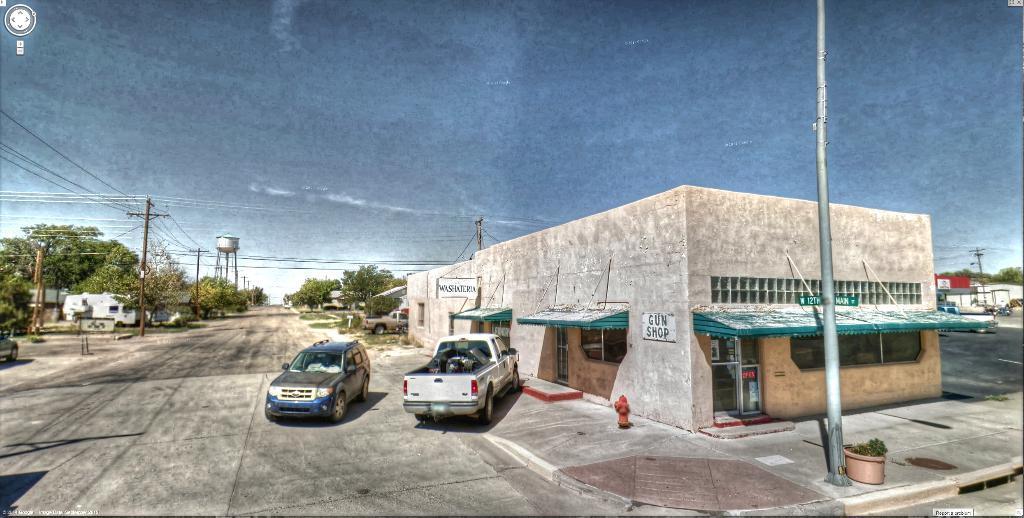Describe this image in one or two sentences. In this image I can see in the middle there are two vehicles on the road, on the right side there is the shop. On the left side there are electric poles and trees, at the top it is the sky. 